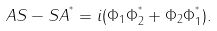Convert formula to latex. <formula><loc_0><loc_0><loc_500><loc_500>A S - S A ^ { ^ { * } } = i ( \Phi _ { 1 } \Phi _ { 2 } ^ { ^ { * } } + \Phi _ { 2 } \Phi _ { 1 } ^ { ^ { * } } ) .</formula> 